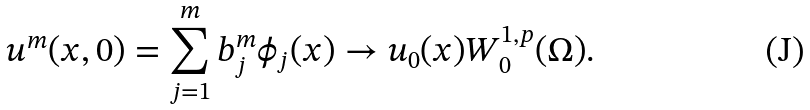Convert formula to latex. <formula><loc_0><loc_0><loc_500><loc_500>u ^ { m } ( x , 0 ) = \sum _ { j = 1 } ^ { m } b _ { j } ^ { m } \phi _ { j } ( x ) \to u _ { 0 } ( x ) W _ { 0 } ^ { 1 , p } ( \Omega ) .</formula> 